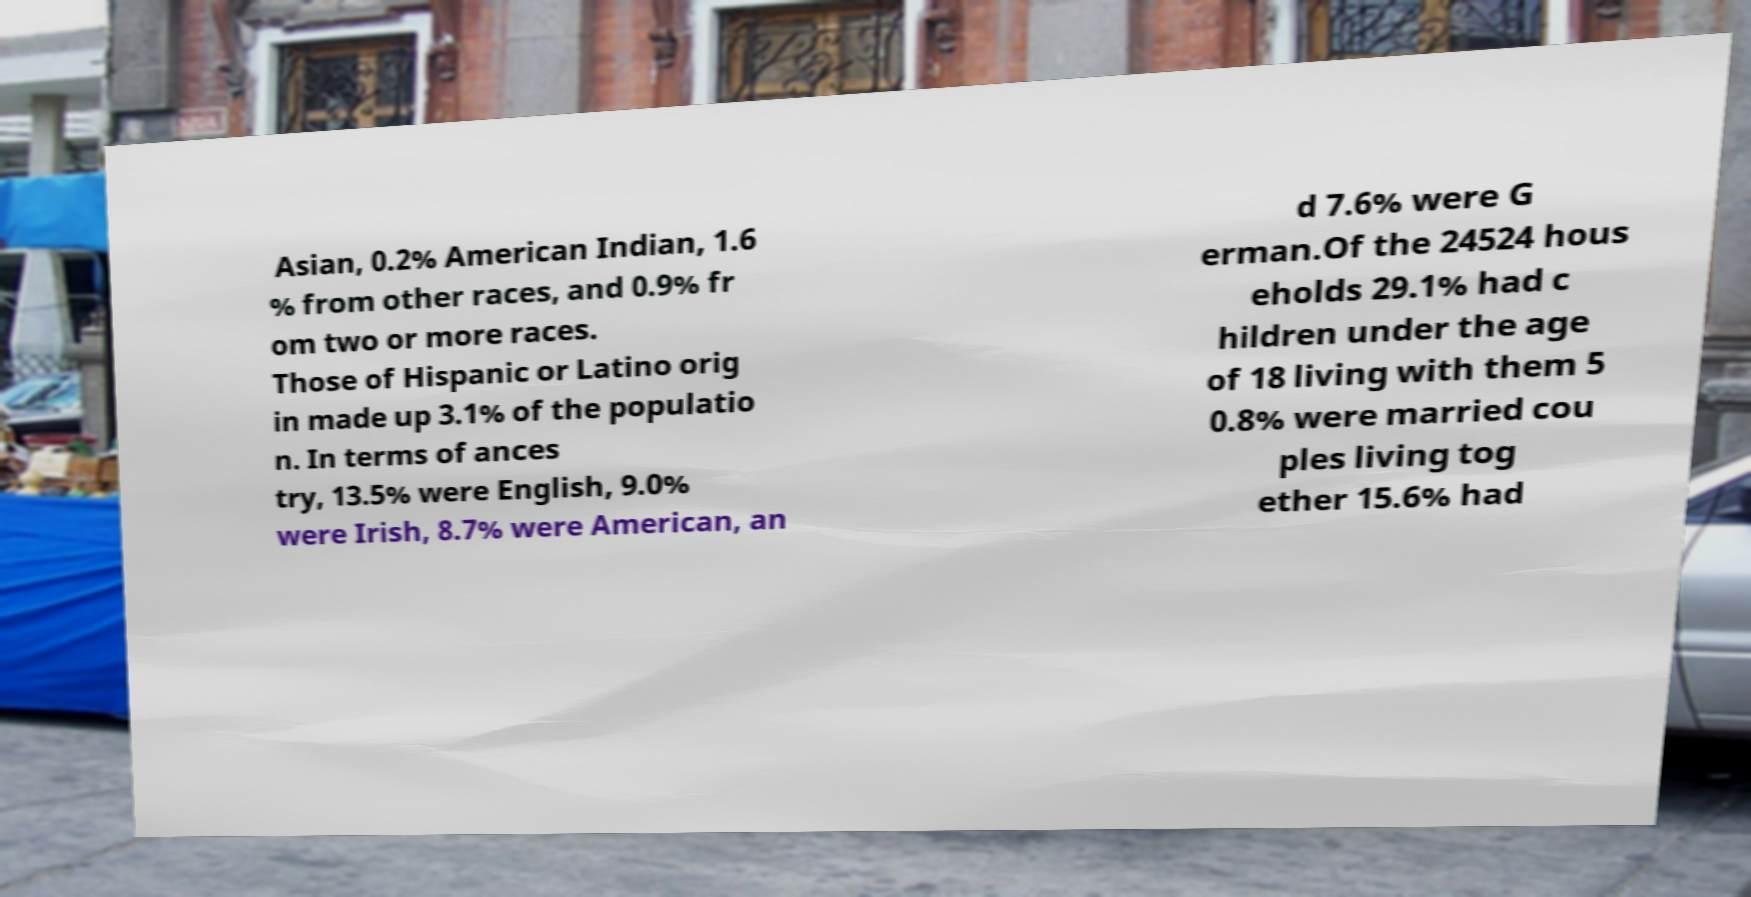There's text embedded in this image that I need extracted. Can you transcribe it verbatim? Asian, 0.2% American Indian, 1.6 % from other races, and 0.9% fr om two or more races. Those of Hispanic or Latino orig in made up 3.1% of the populatio n. In terms of ances try, 13.5% were English, 9.0% were Irish, 8.7% were American, an d 7.6% were G erman.Of the 24524 hous eholds 29.1% had c hildren under the age of 18 living with them 5 0.8% were married cou ples living tog ether 15.6% had 